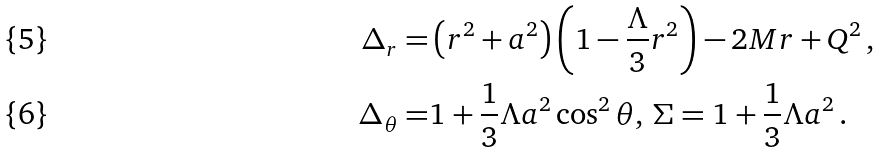<formula> <loc_0><loc_0><loc_500><loc_500>\Delta _ { r } = & \left ( r ^ { 2 } + a ^ { 2 } \right ) \left ( 1 - \frac { \Lambda } { 3 } r ^ { 2 } \right ) - 2 M r + Q ^ { 2 } \, , \\ \Delta _ { \theta } = & 1 + \frac { 1 } { 3 } \Lambda a ^ { 2 } \cos ^ { 2 } \theta , \, \Sigma = 1 + \frac { 1 } { 3 } \Lambda a ^ { 2 } \, .</formula> 